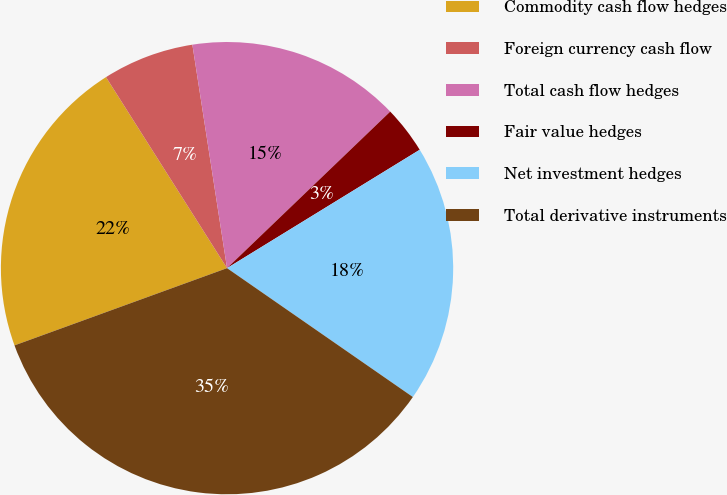<chart> <loc_0><loc_0><loc_500><loc_500><pie_chart><fcel>Commodity cash flow hedges<fcel>Foreign currency cash flow<fcel>Total cash flow hedges<fcel>Fair value hedges<fcel>Net investment hedges<fcel>Total derivative instruments<nl><fcel>21.56%<fcel>6.54%<fcel>15.28%<fcel>3.4%<fcel>18.42%<fcel>34.8%<nl></chart> 